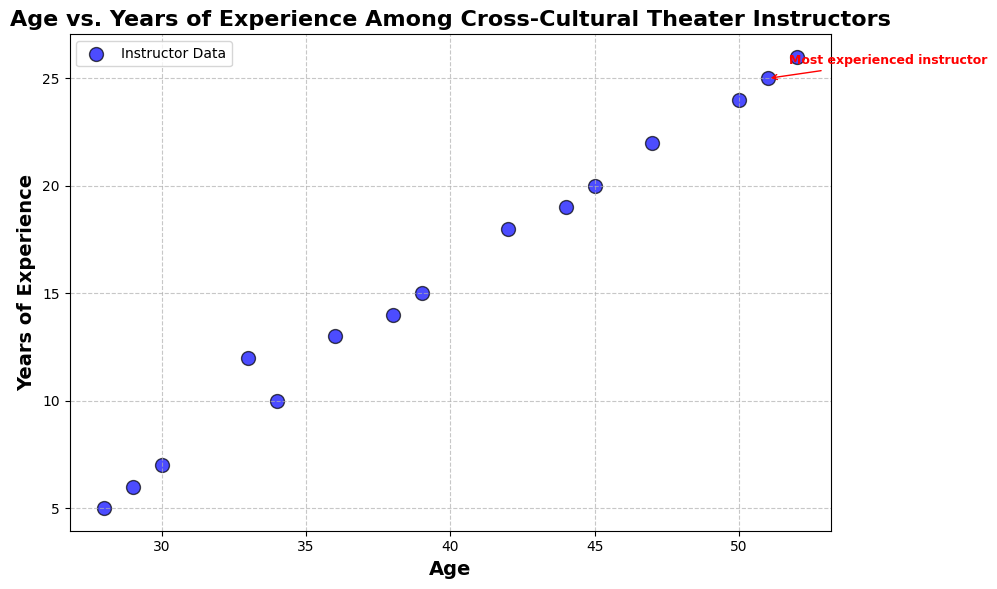What is the age and years of experience of the most experienced instructor in the plot? Locate the text annotation "Most experienced instructor" on the scatter plot. The corresponding point has an age of 51 and 25 years of experience.
Answer: 51 and 25 How many instructors have more than 20 years of experience? Identify the data points above the 20 years of experience mark on the Y-axis. There are four such data points (ages 45, 47, 50, and 52).
Answer: 4 Which instructor has an age closest to the average age of all the instructors? Calculate the average age (28+34+45+51+39+30+42+47+36+29+44+50+38+33+52)/15 = 39.3. The closest age to 39.3 is 39.
Answer: Instructor with age 39 Which two instructors have the smallest age difference, and what is that difference? Compare the ages pairwise to find the smallest difference. The smallest age difference is between the instructors aged 28 and 29, which is a 1-year difference.
Answer: Instructors with ages 28 and 29, 1 year Which age group has the highest range of years of experience, and what is that range? Group the ages into clusters (e.g., 20-30, 31-40, 41-50, 51-60) and compute the range for each group. The 41-50 group has the highest range with years of experience spanning from 18 to 24, so the range is 24 - 18 = 6 years.
Answer: Age group 41-50, 6 years Do older instructors generally have more years of experience? Visually inspect the scatter plot's trend and note that as the age increases, the years of experience tend to increase, indicating a positive correlation.
Answer: Yes Which instructor has the most unusual combination of age and experience, and why is it unusual? Look for outliers or points far from the main trend. Instructor aged 28 with 5 years of experience appears unusual as it's on the lower end of both age and experience in relation to others.
Answer: Instructor aged 28 with 5 years of experience What is the range of ages for instructors with at least 15 years of experience? Consider only the points with 15 or more years of experience and find the age range. The ages are from 39 to 52, so the range is 52 - 39 = 13 years.
Answer: 13 years Is there any instructor with 7 years of experience older than 30 years? Identify the instructor with 7 years of experience and check their age. The instructor is aged 30, which is exactly 30 years and not older.
Answer: No 